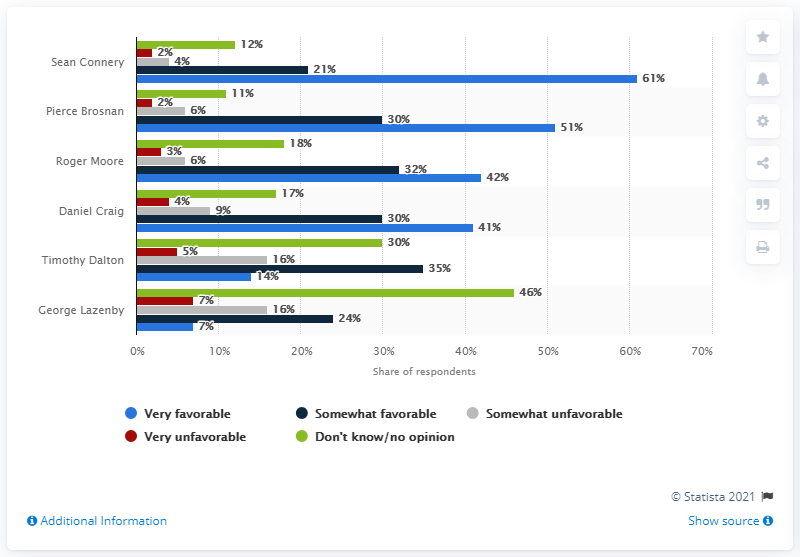Can you tell me how the other actors compared to Sean Connery in terms of favorability? Besides Sean Connery, Pierce Brosnan has a notable favorability, with 51% of respondents giving him a 'very favorable' rating. Roger Moore follows with 42%, and Daniel Craig with 41%. The others rank noticeably lower, indicating a significant gap in popularity. What can you tell me about the least favorable James Bond actor based on the image? George Lazenby appears to be the least favorable James Bond as per the image, with around 46% of respondents viewing him unfavorably. His shorter tenure as Bond might have contributed to lesser popularity. 